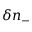Convert formula to latex. <formula><loc_0><loc_0><loc_500><loc_500>\delta n _ { - }</formula> 